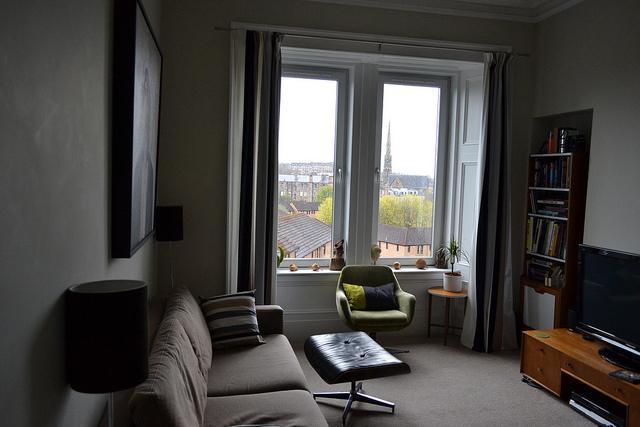How many people sitting at the table?
Give a very brief answer. 0. 